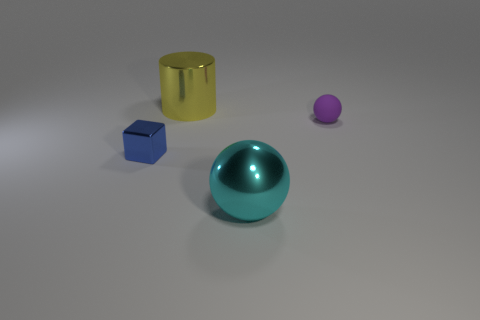Is the number of tiny blue objects greater than the number of large things?
Ensure brevity in your answer.  No. There is a metal thing that is in front of the tiny rubber ball and behind the cyan ball; what shape is it?
Offer a very short reply. Cube. Are any large green matte things visible?
Make the answer very short. No. What material is the purple thing that is the same shape as the big cyan thing?
Your response must be concise. Rubber. What shape is the large metal thing in front of the large object that is behind the small thing on the right side of the blue object?
Your response must be concise. Sphere. What number of other large yellow things are the same shape as the big yellow shiny thing?
Provide a succinct answer. 0. There is a tiny object that is left of the metallic cylinder; does it have the same color as the big thing that is behind the cube?
Your response must be concise. No. What material is the block that is the same size as the purple thing?
Your answer should be compact. Metal. Is there a yellow metal object that has the same size as the blue metallic object?
Ensure brevity in your answer.  No. Is the number of large yellow shiny objects that are behind the tiny cube less than the number of small red metallic cubes?
Make the answer very short. No. 